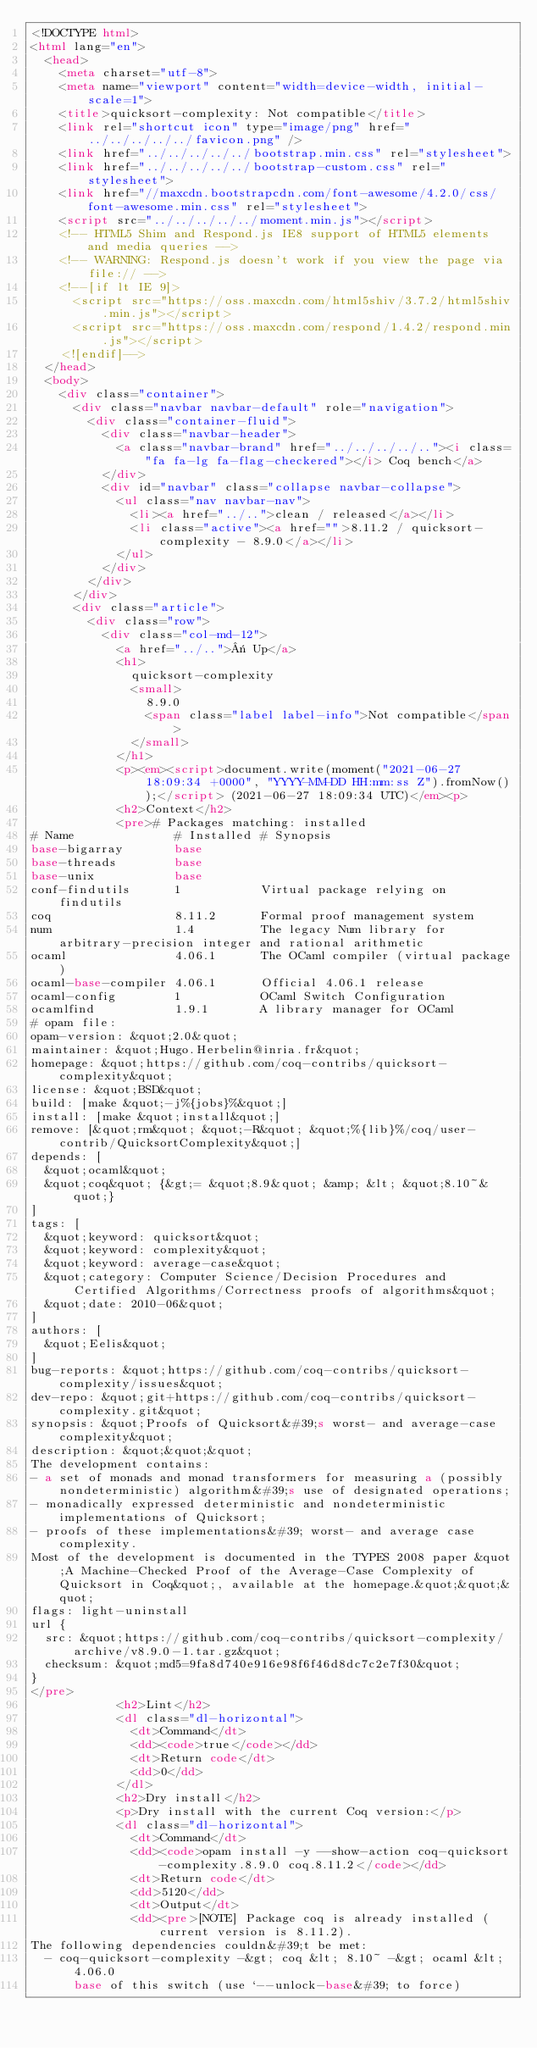<code> <loc_0><loc_0><loc_500><loc_500><_HTML_><!DOCTYPE html>
<html lang="en">
  <head>
    <meta charset="utf-8">
    <meta name="viewport" content="width=device-width, initial-scale=1">
    <title>quicksort-complexity: Not compatible</title>
    <link rel="shortcut icon" type="image/png" href="../../../../../favicon.png" />
    <link href="../../../../../bootstrap.min.css" rel="stylesheet">
    <link href="../../../../../bootstrap-custom.css" rel="stylesheet">
    <link href="//maxcdn.bootstrapcdn.com/font-awesome/4.2.0/css/font-awesome.min.css" rel="stylesheet">
    <script src="../../../../../moment.min.js"></script>
    <!-- HTML5 Shim and Respond.js IE8 support of HTML5 elements and media queries -->
    <!-- WARNING: Respond.js doesn't work if you view the page via file:// -->
    <!--[if lt IE 9]>
      <script src="https://oss.maxcdn.com/html5shiv/3.7.2/html5shiv.min.js"></script>
      <script src="https://oss.maxcdn.com/respond/1.4.2/respond.min.js"></script>
    <![endif]-->
  </head>
  <body>
    <div class="container">
      <div class="navbar navbar-default" role="navigation">
        <div class="container-fluid">
          <div class="navbar-header">
            <a class="navbar-brand" href="../../../../.."><i class="fa fa-lg fa-flag-checkered"></i> Coq bench</a>
          </div>
          <div id="navbar" class="collapse navbar-collapse">
            <ul class="nav navbar-nav">
              <li><a href="../..">clean / released</a></li>
              <li class="active"><a href="">8.11.2 / quicksort-complexity - 8.9.0</a></li>
            </ul>
          </div>
        </div>
      </div>
      <div class="article">
        <div class="row">
          <div class="col-md-12">
            <a href="../..">« Up</a>
            <h1>
              quicksort-complexity
              <small>
                8.9.0
                <span class="label label-info">Not compatible</span>
              </small>
            </h1>
            <p><em><script>document.write(moment("2021-06-27 18:09:34 +0000", "YYYY-MM-DD HH:mm:ss Z").fromNow());</script> (2021-06-27 18:09:34 UTC)</em><p>
            <h2>Context</h2>
            <pre># Packages matching: installed
# Name              # Installed # Synopsis
base-bigarray       base
base-threads        base
base-unix           base
conf-findutils      1           Virtual package relying on findutils
coq                 8.11.2      Formal proof management system
num                 1.4         The legacy Num library for arbitrary-precision integer and rational arithmetic
ocaml               4.06.1      The OCaml compiler (virtual package)
ocaml-base-compiler 4.06.1      Official 4.06.1 release
ocaml-config        1           OCaml Switch Configuration
ocamlfind           1.9.1       A library manager for OCaml
# opam file:
opam-version: &quot;2.0&quot;
maintainer: &quot;Hugo.Herbelin@inria.fr&quot;
homepage: &quot;https://github.com/coq-contribs/quicksort-complexity&quot;
license: &quot;BSD&quot;
build: [make &quot;-j%{jobs}%&quot;]
install: [make &quot;install&quot;]
remove: [&quot;rm&quot; &quot;-R&quot; &quot;%{lib}%/coq/user-contrib/QuicksortComplexity&quot;]
depends: [
  &quot;ocaml&quot;
  &quot;coq&quot; {&gt;= &quot;8.9&quot; &amp; &lt; &quot;8.10~&quot;}
]
tags: [
  &quot;keyword: quicksort&quot;
  &quot;keyword: complexity&quot;
  &quot;keyword: average-case&quot;
  &quot;category: Computer Science/Decision Procedures and Certified Algorithms/Correctness proofs of algorithms&quot;
  &quot;date: 2010-06&quot;
]
authors: [
  &quot;Eelis&quot;
]
bug-reports: &quot;https://github.com/coq-contribs/quicksort-complexity/issues&quot;
dev-repo: &quot;git+https://github.com/coq-contribs/quicksort-complexity.git&quot;
synopsis: &quot;Proofs of Quicksort&#39;s worst- and average-case complexity&quot;
description: &quot;&quot;&quot;
The development contains:
- a set of monads and monad transformers for measuring a (possibly nondeterministic) algorithm&#39;s use of designated operations;
- monadically expressed deterministic and nondeterministic implementations of Quicksort;
- proofs of these implementations&#39; worst- and average case complexity.
Most of the development is documented in the TYPES 2008 paper &quot;A Machine-Checked Proof of the Average-Case Complexity of Quicksort in Coq&quot;, available at the homepage.&quot;&quot;&quot;
flags: light-uninstall
url {
  src: &quot;https://github.com/coq-contribs/quicksort-complexity/archive/v8.9.0-1.tar.gz&quot;
  checksum: &quot;md5=9fa8d740e916e98f6f46d8dc7c2e7f30&quot;
}
</pre>
            <h2>Lint</h2>
            <dl class="dl-horizontal">
              <dt>Command</dt>
              <dd><code>true</code></dd>
              <dt>Return code</dt>
              <dd>0</dd>
            </dl>
            <h2>Dry install</h2>
            <p>Dry install with the current Coq version:</p>
            <dl class="dl-horizontal">
              <dt>Command</dt>
              <dd><code>opam install -y --show-action coq-quicksort-complexity.8.9.0 coq.8.11.2</code></dd>
              <dt>Return code</dt>
              <dd>5120</dd>
              <dt>Output</dt>
              <dd><pre>[NOTE] Package coq is already installed (current version is 8.11.2).
The following dependencies couldn&#39;t be met:
  - coq-quicksort-complexity -&gt; coq &lt; 8.10~ -&gt; ocaml &lt; 4.06.0
      base of this switch (use `--unlock-base&#39; to force)</code> 